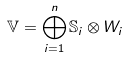<formula> <loc_0><loc_0><loc_500><loc_500>\mathbb { V } = \bigoplus _ { i = 1 } ^ { n } \mathbb { S } _ { i } \otimes W _ { i }</formula> 